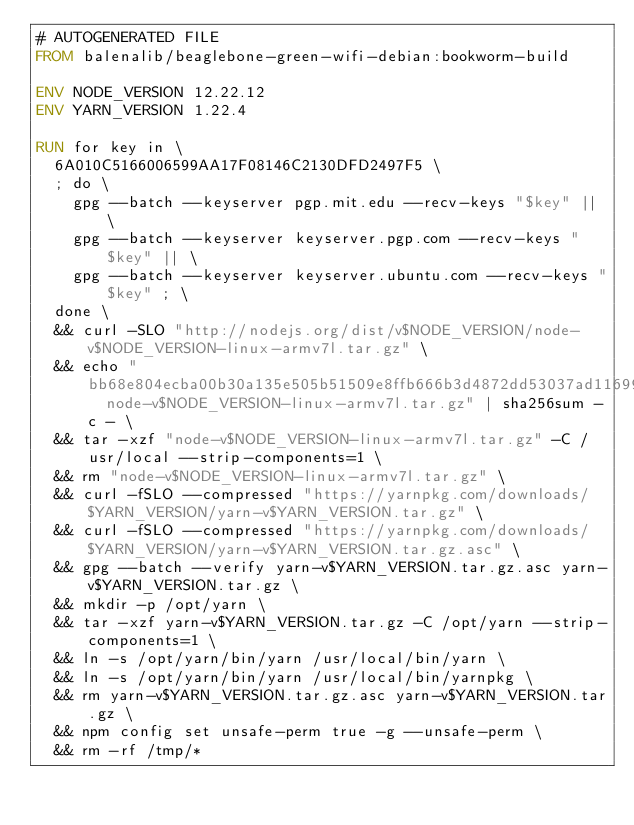Convert code to text. <code><loc_0><loc_0><loc_500><loc_500><_Dockerfile_># AUTOGENERATED FILE
FROM balenalib/beaglebone-green-wifi-debian:bookworm-build

ENV NODE_VERSION 12.22.12
ENV YARN_VERSION 1.22.4

RUN for key in \
	6A010C5166006599AA17F08146C2130DFD2497F5 \
	; do \
		gpg --batch --keyserver pgp.mit.edu --recv-keys "$key" || \
		gpg --batch --keyserver keyserver.pgp.com --recv-keys "$key" || \
		gpg --batch --keyserver keyserver.ubuntu.com --recv-keys "$key" ; \
	done \
	&& curl -SLO "http://nodejs.org/dist/v$NODE_VERSION/node-v$NODE_VERSION-linux-armv7l.tar.gz" \
	&& echo "bb68e804ecba00b30a135e505b51509e8ffb666b3d4872dd53037ad11699174c  node-v$NODE_VERSION-linux-armv7l.tar.gz" | sha256sum -c - \
	&& tar -xzf "node-v$NODE_VERSION-linux-armv7l.tar.gz" -C /usr/local --strip-components=1 \
	&& rm "node-v$NODE_VERSION-linux-armv7l.tar.gz" \
	&& curl -fSLO --compressed "https://yarnpkg.com/downloads/$YARN_VERSION/yarn-v$YARN_VERSION.tar.gz" \
	&& curl -fSLO --compressed "https://yarnpkg.com/downloads/$YARN_VERSION/yarn-v$YARN_VERSION.tar.gz.asc" \
	&& gpg --batch --verify yarn-v$YARN_VERSION.tar.gz.asc yarn-v$YARN_VERSION.tar.gz \
	&& mkdir -p /opt/yarn \
	&& tar -xzf yarn-v$YARN_VERSION.tar.gz -C /opt/yarn --strip-components=1 \
	&& ln -s /opt/yarn/bin/yarn /usr/local/bin/yarn \
	&& ln -s /opt/yarn/bin/yarn /usr/local/bin/yarnpkg \
	&& rm yarn-v$YARN_VERSION.tar.gz.asc yarn-v$YARN_VERSION.tar.gz \
	&& npm config set unsafe-perm true -g --unsafe-perm \
	&& rm -rf /tmp/*
</code> 